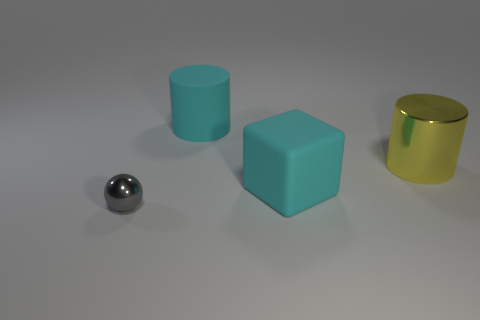Add 2 small things. How many objects exist? 6 Subtract 1 cylinders. How many cylinders are left? 1 Add 2 small yellow things. How many small yellow things exist? 2 Subtract all cyan cylinders. How many cylinders are left? 1 Subtract 0 green cylinders. How many objects are left? 4 Subtract all blocks. How many objects are left? 3 Subtract all yellow cylinders. Subtract all blue spheres. How many cylinders are left? 1 Subtract all gray balls. How many gray cubes are left? 0 Subtract all big blue metal balls. Subtract all rubber blocks. How many objects are left? 3 Add 4 big cyan rubber objects. How many big cyan rubber objects are left? 6 